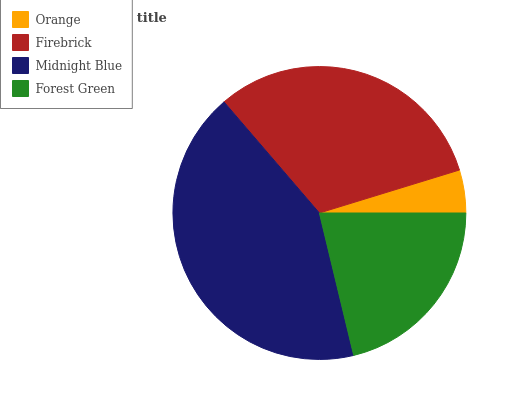Is Orange the minimum?
Answer yes or no. Yes. Is Midnight Blue the maximum?
Answer yes or no. Yes. Is Firebrick the minimum?
Answer yes or no. No. Is Firebrick the maximum?
Answer yes or no. No. Is Firebrick greater than Orange?
Answer yes or no. Yes. Is Orange less than Firebrick?
Answer yes or no. Yes. Is Orange greater than Firebrick?
Answer yes or no. No. Is Firebrick less than Orange?
Answer yes or no. No. Is Firebrick the high median?
Answer yes or no. Yes. Is Forest Green the low median?
Answer yes or no. Yes. Is Midnight Blue the high median?
Answer yes or no. No. Is Orange the low median?
Answer yes or no. No. 